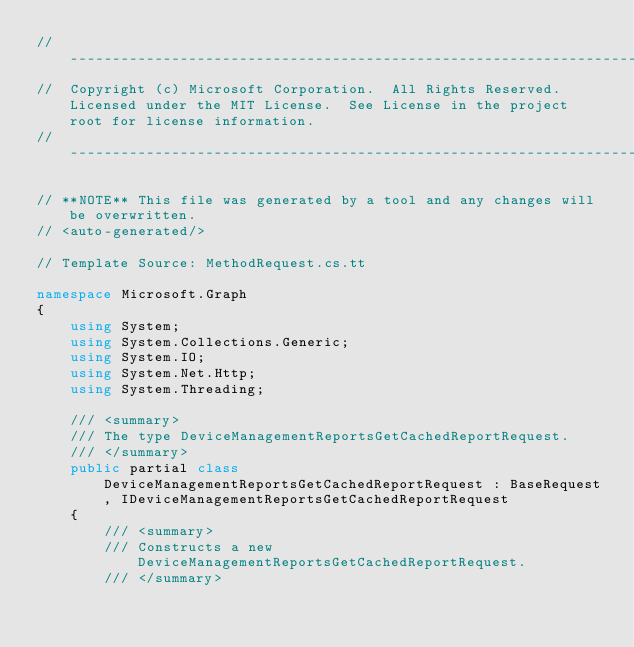<code> <loc_0><loc_0><loc_500><loc_500><_C#_>// ------------------------------------------------------------------------------
//  Copyright (c) Microsoft Corporation.  All Rights Reserved.  Licensed under the MIT License.  See License in the project root for license information.
// ------------------------------------------------------------------------------

// **NOTE** This file was generated by a tool and any changes will be overwritten.
// <auto-generated/>

// Template Source: MethodRequest.cs.tt

namespace Microsoft.Graph
{
    using System;
    using System.Collections.Generic;
    using System.IO;
    using System.Net.Http;
    using System.Threading;

    /// <summary>
    /// The type DeviceManagementReportsGetCachedReportRequest.
    /// </summary>
    public partial class DeviceManagementReportsGetCachedReportRequest : BaseRequest, IDeviceManagementReportsGetCachedReportRequest
    {
        /// <summary>
        /// Constructs a new DeviceManagementReportsGetCachedReportRequest.
        /// </summary></code> 